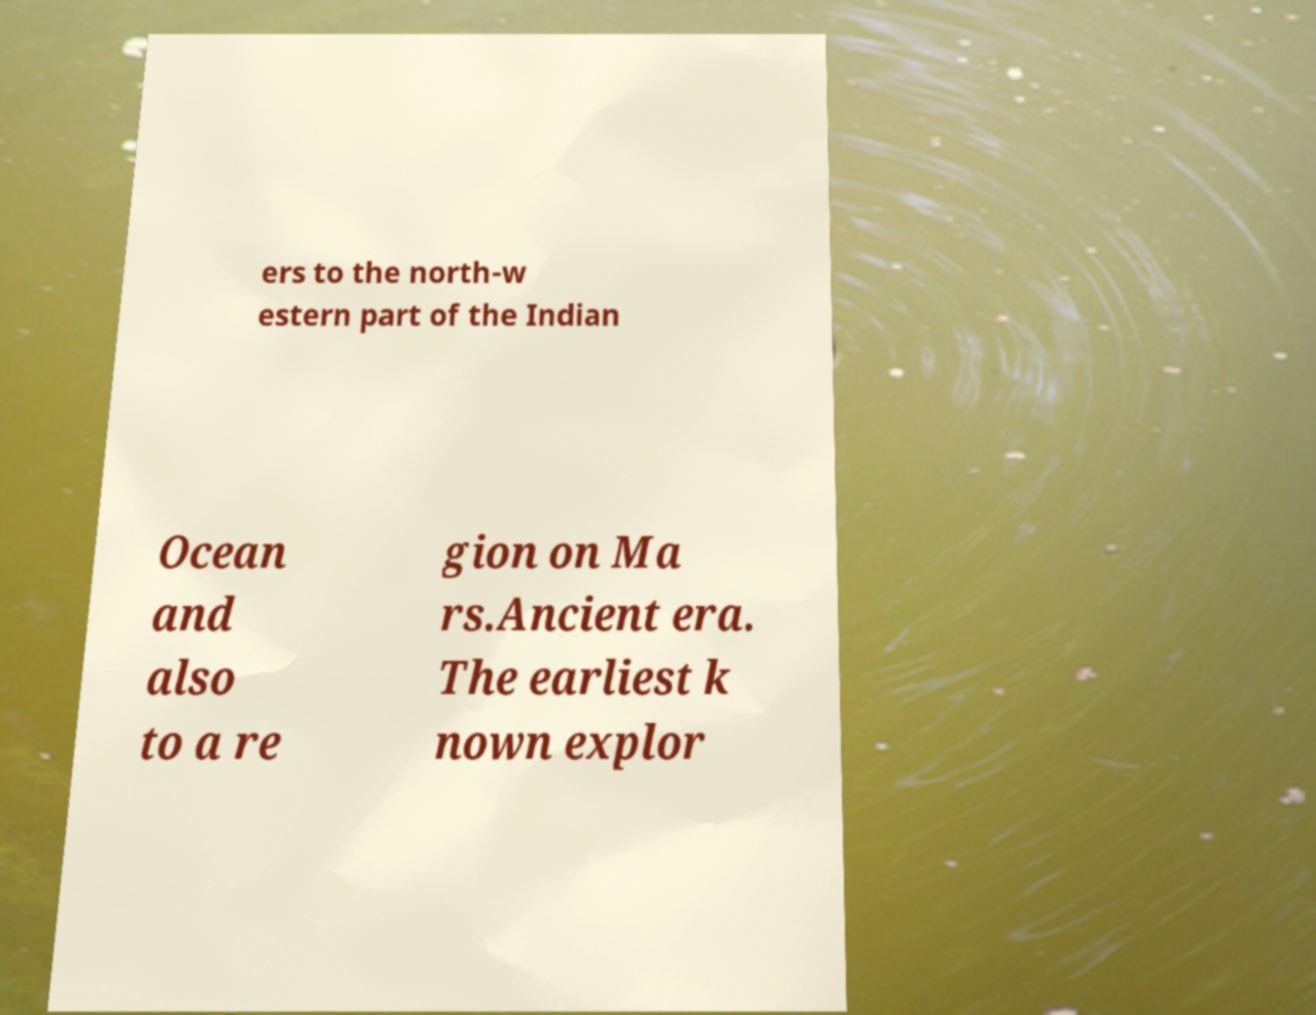There's text embedded in this image that I need extracted. Can you transcribe it verbatim? ers to the north-w estern part of the Indian Ocean and also to a re gion on Ma rs.Ancient era. The earliest k nown explor 